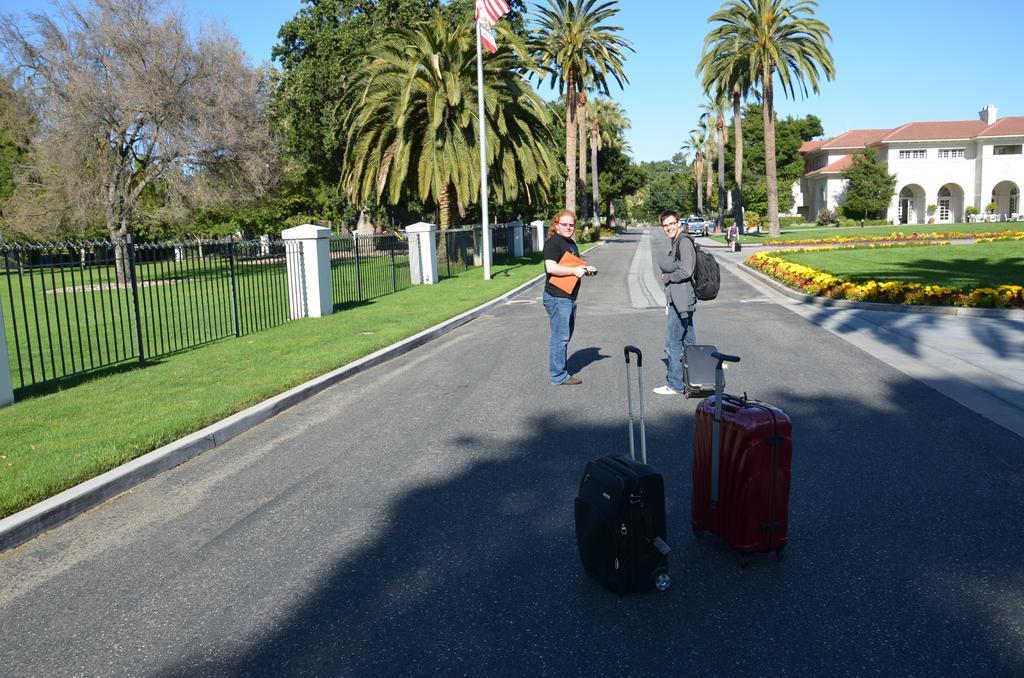Describe this image in one or two sentences. In the image there are two person stood on road and luggages in background of them. On either sides on road there is garden and there is flag in middle of the garden. On right side there is home and above its sky crystal clear. 